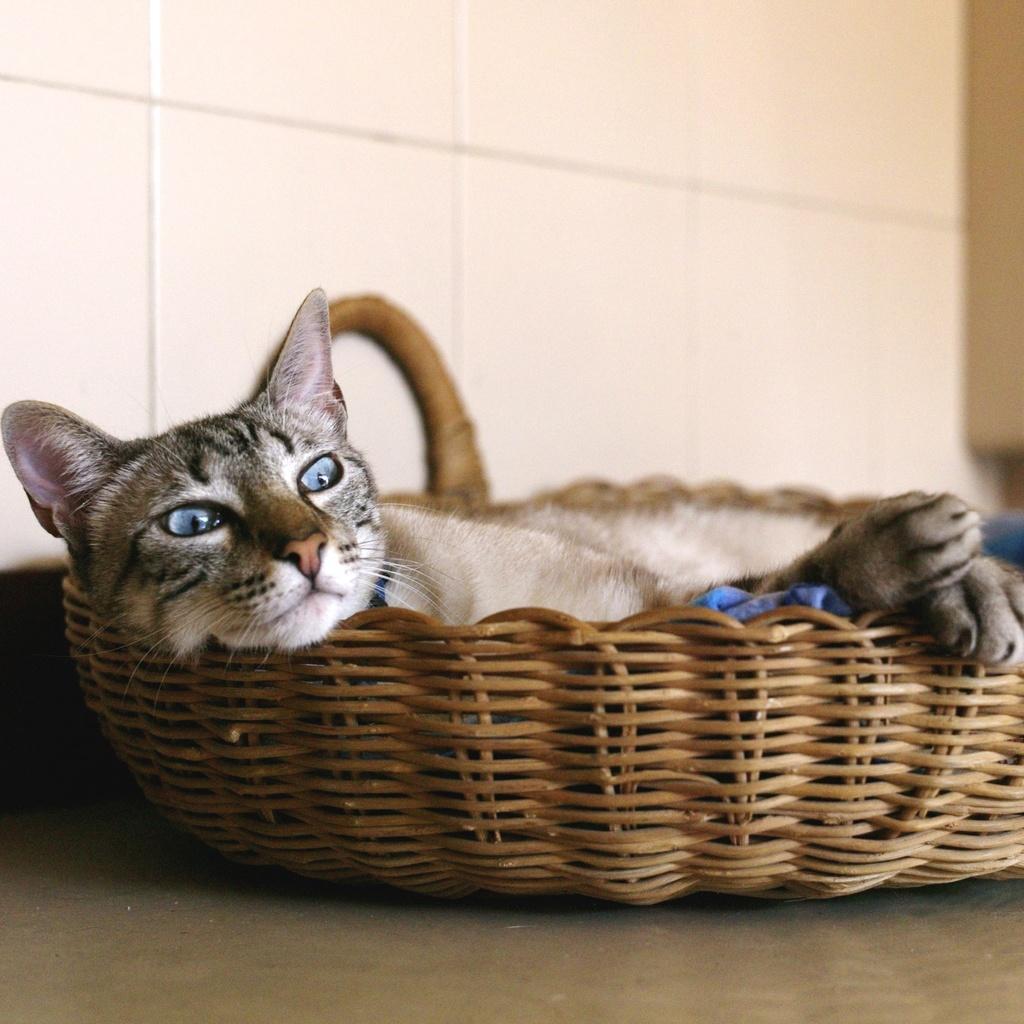Can you describe this image briefly? In this image there is a cat in the basket. In the background there is a wall. 